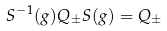<formula> <loc_0><loc_0><loc_500><loc_500>S ^ { - 1 } ( g ) Q _ { \pm } S ( g ) = Q _ { \pm }</formula> 